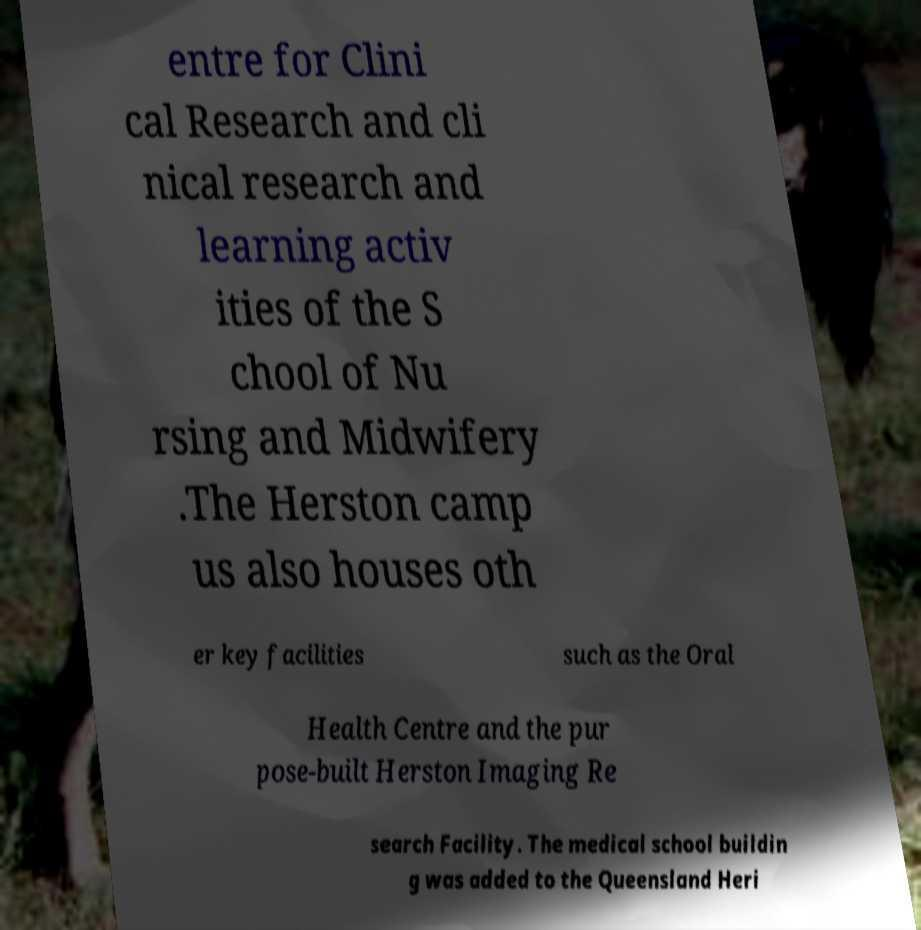Can you accurately transcribe the text from the provided image for me? entre for Clini cal Research and cli nical research and learning activ ities of the S chool of Nu rsing and Midwifery .The Herston camp us also houses oth er key facilities such as the Oral Health Centre and the pur pose-built Herston Imaging Re search Facility. The medical school buildin g was added to the Queensland Heri 